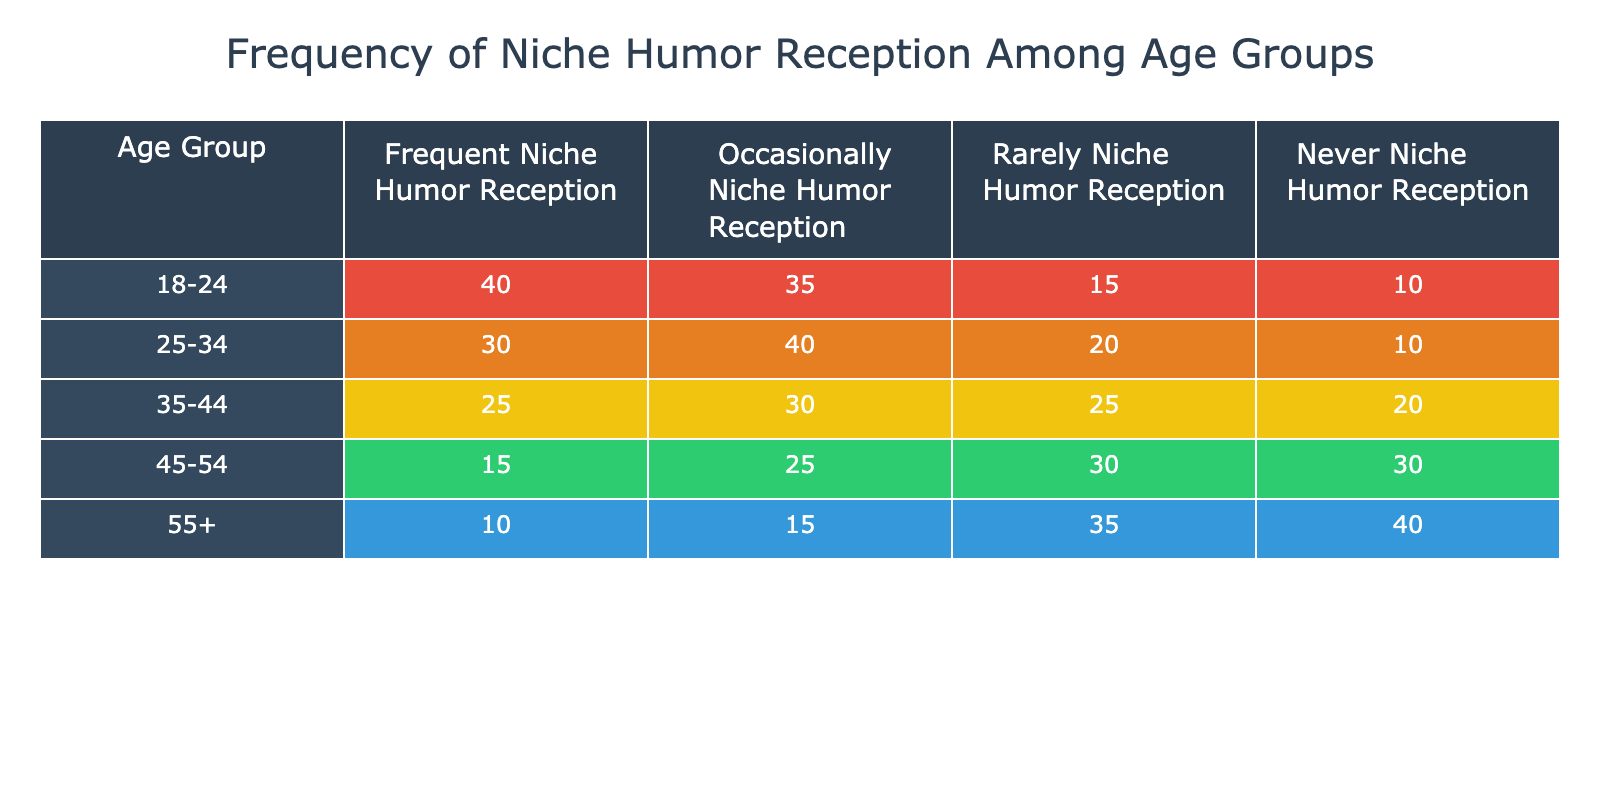What is the highest frequency of niche humor reception among the age groups? The highest frequency is found in the 'Frequent Niche Humor Reception' category of the '18-24' age group with a value of 40.
Answer: 40 Which age group has the lowest percentage of people that 'Never Niche Humor Reception'? To determine this, we look at the 'Never Niche Humor Reception' column and find that the '18-24' age group has the lowest value of 10.
Answer: 18-24 What is the total number of people in the 25-34 age group who receive niche humor occasionally or more frequently? To find this total, we sum the values in the 'Frequent Niche Humor Reception' (30) and 'Occasionally Niche Humor Reception' (40) columns for the '25-34' age group. The total is 30 + 40 = 70.
Answer: 70 Is it true that individuals aged 55 and above predominantly receive niche humor rarely or never? In the '55+' age group, the sum of 'Rarely Niche Humor Reception' (35) and 'Never Niche Humor Reception' (40) totals to 75, which is greater than the number of individuals who receive it frequently (10) or occasionally (15). Therefore, it is true.
Answer: Yes What is the average number of people across all age groups who receive niche humor frequently? We calculate the average by adding up the 'Frequent Niche Humor Reception' values for all age groups: 40 + 30 + 25 + 15 + 10 = 120. There are 5 age groups, so the average is 120/5 = 24.
Answer: 24 What percentage of the 45-54 age group receives niche humor occasionally? For the 45-54 age group, the 'Occasionally Niche Humor Reception' is 25. To find the percentage, we see how many total responses there are for that age group: 15 (frequent) + 25 (occasional) + 30 (rarely) + 30 (never) = 100. The percentage is (25/100) * 100 = 25%.
Answer: 25% In the 35-44 age group, how many individuals receive niche humor either rarely or never? For the '35-44' age group, the counts for 'Rarely Niche Humor Reception' are 25 and 'Never Niche Humor Reception' is 20. Summing these gives us 25 + 20 = 45.
Answer: 45 Which age group has a close balance between those who receive niche humor occasionally and those who receive it rarely? Looking at the 'Occasionally Niche Humor Reception' and 'Rarely Niche Humor Reception' figures, the 35-44 age group has 30 for occasionally and 25 for rarely, which indicates a close balance.
Answer: 35-44 